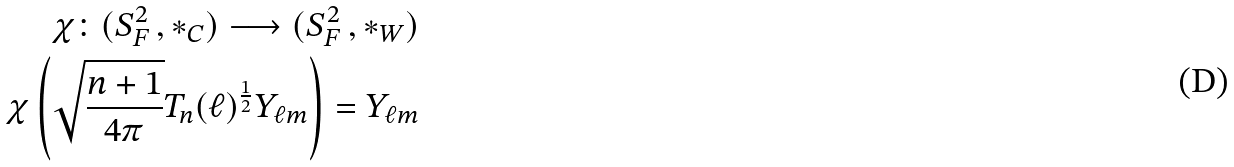Convert formula to latex. <formula><loc_0><loc_0><loc_500><loc_500>\chi \colon ( S _ { F } ^ { 2 } \, , * _ { C } ) \longrightarrow ( S _ { F } ^ { 2 } \, , * _ { W } ) \\ \chi \left ( \sqrt { \frac { n + 1 } { 4 \pi } } T _ { n } ( \ell ) ^ { \frac { 1 } { 2 } } Y _ { \ell m } \right ) = Y _ { \ell m }</formula> 